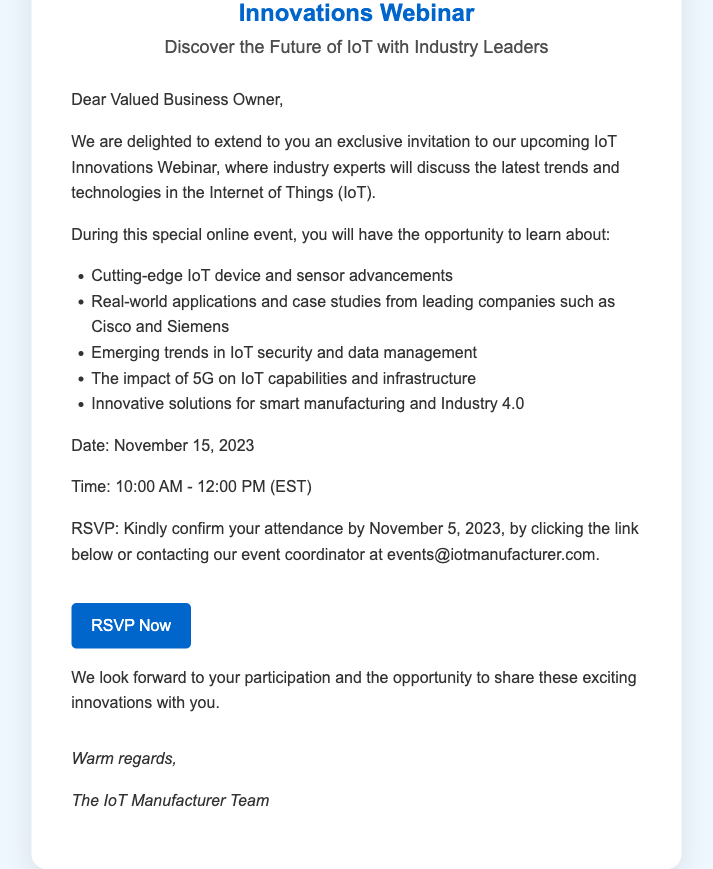What is the date of the webinar? The date of the webinar is clearly mentioned in the document as November 15, 2023.
Answer: November 15, 2023 What is the time of the webinar? The document specifies the time as 10:00 AM - 12:00 PM (EST).
Answer: 10:00 AM - 12:00 PM (EST) What is required to confirm attendance? The RSVP section explains that attendance should be confirmed by clicking a link or contacting the event coordinator.
Answer: RSVP Who is invited to the webinar? The invitation addresses "Dear Valued Business Owner," indicating the intended audience.
Answer: Business Owner What topic will be discussed regarding IoT? The document lists "Emerging trends in IoT security and data management" as one of the topics.
Answer: IoT security and data management What is the RSVP deadline? The deadline to confirm attendance is mentioned as November 5, 2023.
Answer: November 5, 2023 What will attendees learn about 5G? The document states that attendees will learn about "The impact of 5G on IoT capabilities and infrastructure."
Answer: Impact of 5G What type of invitation is this document? The document presents an "Exclusive Invitation" for the webinar.
Answer: Exclusive Invitation 